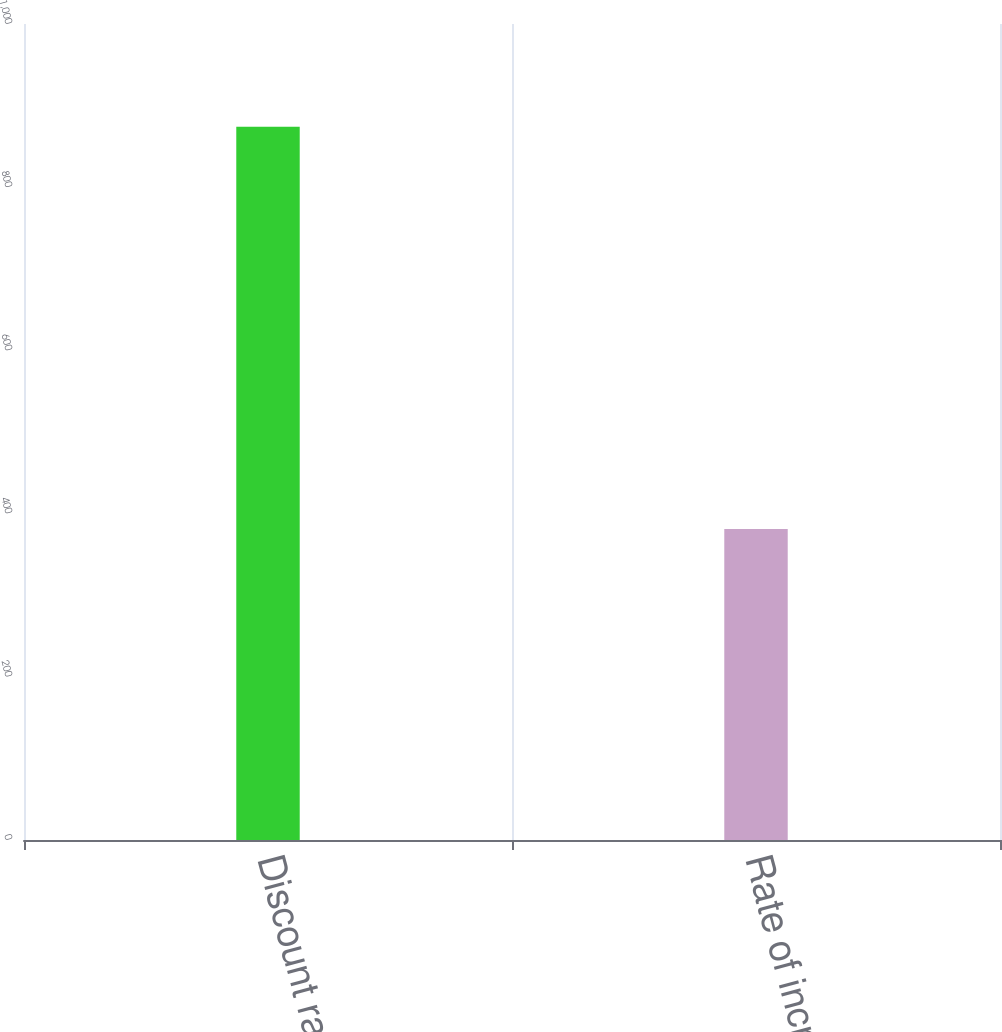Convert chart. <chart><loc_0><loc_0><loc_500><loc_500><bar_chart><fcel>Discount rate<fcel>Rate of increase in<nl><fcel>874<fcel>381<nl></chart> 